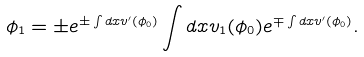Convert formula to latex. <formula><loc_0><loc_0><loc_500><loc_500>\phi _ { 1 } = \pm e ^ { \pm \int d x v ^ { \prime } ( \phi _ { 0 } ) } \int d x v _ { 1 } ( \phi _ { 0 } ) e ^ { \mp \int d x v ^ { \prime } ( \phi _ { 0 } ) } .</formula> 